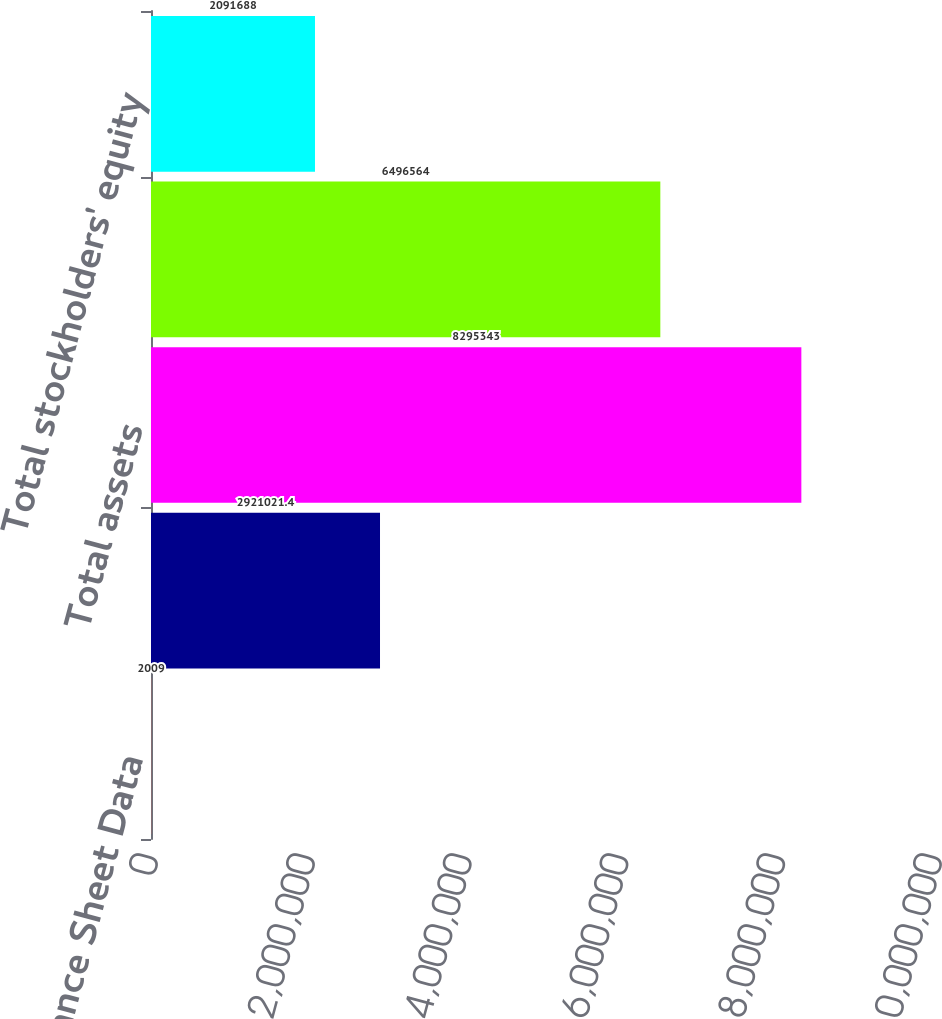<chart> <loc_0><loc_0><loc_500><loc_500><bar_chart><fcel>Balance Sheet Data<fcel>Cash cash equivalents and<fcel>Total assets<fcel>Long-term debt and capital<fcel>Total stockholders' equity<nl><fcel>2009<fcel>2.92102e+06<fcel>8.29534e+06<fcel>6.49656e+06<fcel>2.09169e+06<nl></chart> 